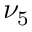Convert formula to latex. <formula><loc_0><loc_0><loc_500><loc_500>\nu _ { 5 }</formula> 